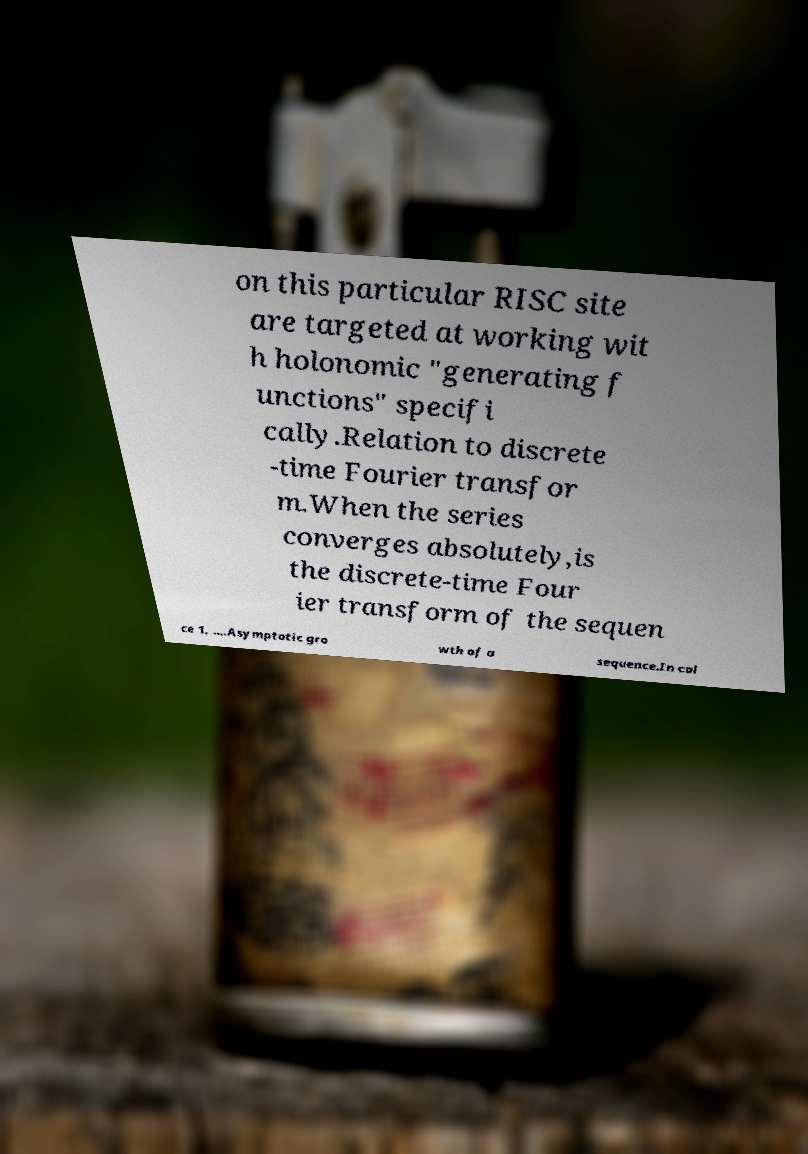Please read and relay the text visible in this image. What does it say? on this particular RISC site are targeted at working wit h holonomic "generating f unctions" specifi cally.Relation to discrete -time Fourier transfor m.When the series converges absolutely,is the discrete-time Four ier transform of the sequen ce 1, ….Asymptotic gro wth of a sequence.In cal 